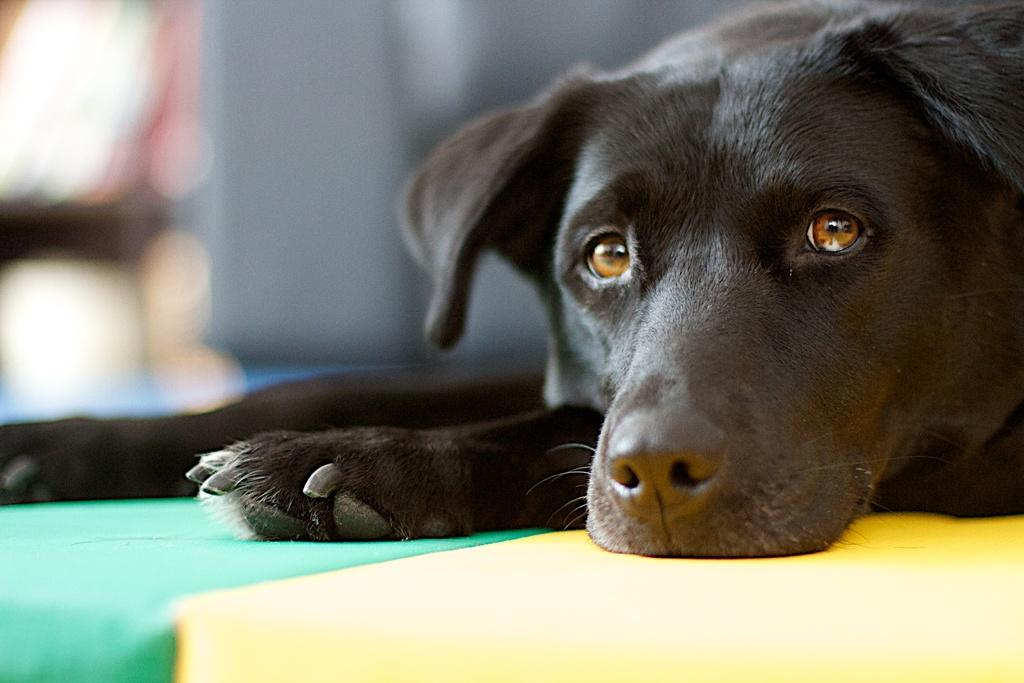What animal is located on the right side of the image? There is a dog on the right side of the image. Can you describe the background of the image? The background of the image is blurry. What type of gold jewelry is the dog wearing in the image? There is no gold jewelry visible on the dog in the image. Can you tell me how many basketballs are in the image? There are no basketballs present in the image. 